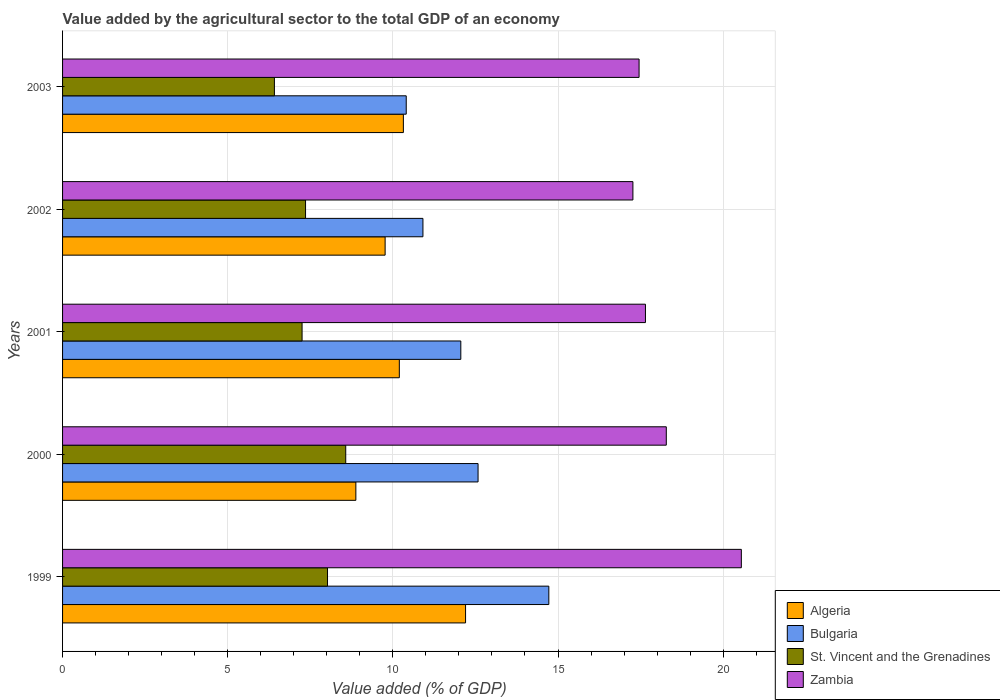How many bars are there on the 1st tick from the bottom?
Ensure brevity in your answer.  4. What is the value added by the agricultural sector to the total GDP in St. Vincent and the Grenadines in 2000?
Give a very brief answer. 8.57. Across all years, what is the maximum value added by the agricultural sector to the total GDP in St. Vincent and the Grenadines?
Your answer should be very brief. 8.57. Across all years, what is the minimum value added by the agricultural sector to the total GDP in Algeria?
Provide a succinct answer. 8.88. In which year was the value added by the agricultural sector to the total GDP in Algeria maximum?
Give a very brief answer. 1999. In which year was the value added by the agricultural sector to the total GDP in Algeria minimum?
Keep it short and to the point. 2000. What is the total value added by the agricultural sector to the total GDP in St. Vincent and the Grenadines in the graph?
Ensure brevity in your answer.  37.62. What is the difference between the value added by the agricultural sector to the total GDP in Zambia in 1999 and that in 2001?
Give a very brief answer. 2.9. What is the difference between the value added by the agricultural sector to the total GDP in Zambia in 1999 and the value added by the agricultural sector to the total GDP in St. Vincent and the Grenadines in 2003?
Your answer should be very brief. 14.14. What is the average value added by the agricultural sector to the total GDP in Bulgaria per year?
Provide a succinct answer. 12.13. In the year 2002, what is the difference between the value added by the agricultural sector to the total GDP in St. Vincent and the Grenadines and value added by the agricultural sector to the total GDP in Zambia?
Your response must be concise. -9.91. What is the ratio of the value added by the agricultural sector to the total GDP in St. Vincent and the Grenadines in 1999 to that in 2000?
Give a very brief answer. 0.94. What is the difference between the highest and the second highest value added by the agricultural sector to the total GDP in Bulgaria?
Offer a very short reply. 2.14. What is the difference between the highest and the lowest value added by the agricultural sector to the total GDP in Bulgaria?
Your response must be concise. 4.32. In how many years, is the value added by the agricultural sector to the total GDP in Bulgaria greater than the average value added by the agricultural sector to the total GDP in Bulgaria taken over all years?
Offer a very short reply. 2. What does the 4th bar from the bottom in 2001 represents?
Keep it short and to the point. Zambia. Is it the case that in every year, the sum of the value added by the agricultural sector to the total GDP in Zambia and value added by the agricultural sector to the total GDP in St. Vincent and the Grenadines is greater than the value added by the agricultural sector to the total GDP in Algeria?
Your answer should be very brief. Yes. How many years are there in the graph?
Your answer should be very brief. 5. What is the difference between two consecutive major ticks on the X-axis?
Your response must be concise. 5. Does the graph contain grids?
Provide a short and direct response. Yes. How many legend labels are there?
Ensure brevity in your answer.  4. How are the legend labels stacked?
Offer a terse response. Vertical. What is the title of the graph?
Provide a short and direct response. Value added by the agricultural sector to the total GDP of an economy. What is the label or title of the X-axis?
Keep it short and to the point. Value added (% of GDP). What is the Value added (% of GDP) of Algeria in 1999?
Give a very brief answer. 12.2. What is the Value added (% of GDP) in Bulgaria in 1999?
Offer a terse response. 14.72. What is the Value added (% of GDP) of St. Vincent and the Grenadines in 1999?
Your answer should be compact. 8.02. What is the Value added (% of GDP) of Zambia in 1999?
Offer a very short reply. 20.55. What is the Value added (% of GDP) of Algeria in 2000?
Make the answer very short. 8.88. What is the Value added (% of GDP) of Bulgaria in 2000?
Your answer should be compact. 12.58. What is the Value added (% of GDP) of St. Vincent and the Grenadines in 2000?
Your answer should be compact. 8.57. What is the Value added (% of GDP) of Zambia in 2000?
Provide a short and direct response. 18.28. What is the Value added (% of GDP) in Algeria in 2001?
Make the answer very short. 10.2. What is the Value added (% of GDP) of Bulgaria in 2001?
Give a very brief answer. 12.06. What is the Value added (% of GDP) of St. Vincent and the Grenadines in 2001?
Ensure brevity in your answer.  7.25. What is the Value added (% of GDP) of Zambia in 2001?
Keep it short and to the point. 17.65. What is the Value added (% of GDP) of Algeria in 2002?
Your answer should be very brief. 9.77. What is the Value added (% of GDP) in Bulgaria in 2002?
Your answer should be compact. 10.91. What is the Value added (% of GDP) in St. Vincent and the Grenadines in 2002?
Give a very brief answer. 7.36. What is the Value added (% of GDP) of Zambia in 2002?
Your answer should be compact. 17.27. What is the Value added (% of GDP) in Algeria in 2003?
Keep it short and to the point. 10.32. What is the Value added (% of GDP) in Bulgaria in 2003?
Your response must be concise. 10.4. What is the Value added (% of GDP) of St. Vincent and the Grenadines in 2003?
Ensure brevity in your answer.  6.41. What is the Value added (% of GDP) in Zambia in 2003?
Offer a very short reply. 17.45. Across all years, what is the maximum Value added (% of GDP) in Algeria?
Your answer should be very brief. 12.2. Across all years, what is the maximum Value added (% of GDP) in Bulgaria?
Provide a short and direct response. 14.72. Across all years, what is the maximum Value added (% of GDP) in St. Vincent and the Grenadines?
Give a very brief answer. 8.57. Across all years, what is the maximum Value added (% of GDP) in Zambia?
Keep it short and to the point. 20.55. Across all years, what is the minimum Value added (% of GDP) of Algeria?
Give a very brief answer. 8.88. Across all years, what is the minimum Value added (% of GDP) of Bulgaria?
Make the answer very short. 10.4. Across all years, what is the minimum Value added (% of GDP) in St. Vincent and the Grenadines?
Your response must be concise. 6.41. Across all years, what is the minimum Value added (% of GDP) of Zambia?
Make the answer very short. 17.27. What is the total Value added (% of GDP) in Algeria in the graph?
Give a very brief answer. 51.36. What is the total Value added (% of GDP) in Bulgaria in the graph?
Ensure brevity in your answer.  60.67. What is the total Value added (% of GDP) of St. Vincent and the Grenadines in the graph?
Keep it short and to the point. 37.62. What is the total Value added (% of GDP) in Zambia in the graph?
Ensure brevity in your answer.  91.2. What is the difference between the Value added (% of GDP) of Algeria in 1999 and that in 2000?
Provide a succinct answer. 3.32. What is the difference between the Value added (% of GDP) of Bulgaria in 1999 and that in 2000?
Your answer should be very brief. 2.14. What is the difference between the Value added (% of GDP) in St. Vincent and the Grenadines in 1999 and that in 2000?
Keep it short and to the point. -0.55. What is the difference between the Value added (% of GDP) in Zambia in 1999 and that in 2000?
Provide a short and direct response. 2.27. What is the difference between the Value added (% of GDP) in Algeria in 1999 and that in 2001?
Your answer should be very brief. 2.01. What is the difference between the Value added (% of GDP) of Bulgaria in 1999 and that in 2001?
Provide a succinct answer. 2.66. What is the difference between the Value added (% of GDP) in St. Vincent and the Grenadines in 1999 and that in 2001?
Keep it short and to the point. 0.77. What is the difference between the Value added (% of GDP) of Zambia in 1999 and that in 2001?
Provide a succinct answer. 2.9. What is the difference between the Value added (% of GDP) in Algeria in 1999 and that in 2002?
Your response must be concise. 2.44. What is the difference between the Value added (% of GDP) in Bulgaria in 1999 and that in 2002?
Offer a terse response. 3.81. What is the difference between the Value added (% of GDP) of St. Vincent and the Grenadines in 1999 and that in 2002?
Offer a very short reply. 0.67. What is the difference between the Value added (% of GDP) of Zambia in 1999 and that in 2002?
Offer a terse response. 3.28. What is the difference between the Value added (% of GDP) of Algeria in 1999 and that in 2003?
Make the answer very short. 1.88. What is the difference between the Value added (% of GDP) of Bulgaria in 1999 and that in 2003?
Your answer should be very brief. 4.32. What is the difference between the Value added (% of GDP) of St. Vincent and the Grenadines in 1999 and that in 2003?
Provide a succinct answer. 1.61. What is the difference between the Value added (% of GDP) of Zambia in 1999 and that in 2003?
Keep it short and to the point. 3.1. What is the difference between the Value added (% of GDP) of Algeria in 2000 and that in 2001?
Give a very brief answer. -1.32. What is the difference between the Value added (% of GDP) in Bulgaria in 2000 and that in 2001?
Ensure brevity in your answer.  0.52. What is the difference between the Value added (% of GDP) in St. Vincent and the Grenadines in 2000 and that in 2001?
Give a very brief answer. 1.32. What is the difference between the Value added (% of GDP) in Zambia in 2000 and that in 2001?
Offer a terse response. 0.63. What is the difference between the Value added (% of GDP) of Algeria in 2000 and that in 2002?
Give a very brief answer. -0.89. What is the difference between the Value added (% of GDP) of Bulgaria in 2000 and that in 2002?
Your answer should be compact. 1.67. What is the difference between the Value added (% of GDP) in St. Vincent and the Grenadines in 2000 and that in 2002?
Give a very brief answer. 1.22. What is the difference between the Value added (% of GDP) in Zambia in 2000 and that in 2002?
Your answer should be very brief. 1.01. What is the difference between the Value added (% of GDP) of Algeria in 2000 and that in 2003?
Offer a terse response. -1.44. What is the difference between the Value added (% of GDP) of Bulgaria in 2000 and that in 2003?
Provide a succinct answer. 2.17. What is the difference between the Value added (% of GDP) in St. Vincent and the Grenadines in 2000 and that in 2003?
Offer a very short reply. 2.16. What is the difference between the Value added (% of GDP) in Zambia in 2000 and that in 2003?
Your answer should be compact. 0.82. What is the difference between the Value added (% of GDP) in Algeria in 2001 and that in 2002?
Provide a succinct answer. 0.43. What is the difference between the Value added (% of GDP) of Bulgaria in 2001 and that in 2002?
Your response must be concise. 1.15. What is the difference between the Value added (% of GDP) in St. Vincent and the Grenadines in 2001 and that in 2002?
Provide a short and direct response. -0.1. What is the difference between the Value added (% of GDP) in Zambia in 2001 and that in 2002?
Your answer should be very brief. 0.38. What is the difference between the Value added (% of GDP) in Algeria in 2001 and that in 2003?
Offer a very short reply. -0.12. What is the difference between the Value added (% of GDP) of Bulgaria in 2001 and that in 2003?
Ensure brevity in your answer.  1.65. What is the difference between the Value added (% of GDP) in St. Vincent and the Grenadines in 2001 and that in 2003?
Offer a terse response. 0.84. What is the difference between the Value added (% of GDP) of Zambia in 2001 and that in 2003?
Give a very brief answer. 0.19. What is the difference between the Value added (% of GDP) of Algeria in 2002 and that in 2003?
Give a very brief answer. -0.55. What is the difference between the Value added (% of GDP) of Bulgaria in 2002 and that in 2003?
Offer a very short reply. 0.51. What is the difference between the Value added (% of GDP) in St. Vincent and the Grenadines in 2002 and that in 2003?
Provide a short and direct response. 0.94. What is the difference between the Value added (% of GDP) of Zambia in 2002 and that in 2003?
Your answer should be compact. -0.19. What is the difference between the Value added (% of GDP) of Algeria in 1999 and the Value added (% of GDP) of Bulgaria in 2000?
Offer a terse response. -0.38. What is the difference between the Value added (% of GDP) in Algeria in 1999 and the Value added (% of GDP) in St. Vincent and the Grenadines in 2000?
Your response must be concise. 3.63. What is the difference between the Value added (% of GDP) in Algeria in 1999 and the Value added (% of GDP) in Zambia in 2000?
Make the answer very short. -6.08. What is the difference between the Value added (% of GDP) in Bulgaria in 1999 and the Value added (% of GDP) in St. Vincent and the Grenadines in 2000?
Keep it short and to the point. 6.15. What is the difference between the Value added (% of GDP) of Bulgaria in 1999 and the Value added (% of GDP) of Zambia in 2000?
Your answer should be compact. -3.56. What is the difference between the Value added (% of GDP) in St. Vincent and the Grenadines in 1999 and the Value added (% of GDP) in Zambia in 2000?
Keep it short and to the point. -10.26. What is the difference between the Value added (% of GDP) in Algeria in 1999 and the Value added (% of GDP) in Bulgaria in 2001?
Provide a short and direct response. 0.14. What is the difference between the Value added (% of GDP) in Algeria in 1999 and the Value added (% of GDP) in St. Vincent and the Grenadines in 2001?
Provide a succinct answer. 4.95. What is the difference between the Value added (% of GDP) of Algeria in 1999 and the Value added (% of GDP) of Zambia in 2001?
Offer a very short reply. -5.45. What is the difference between the Value added (% of GDP) of Bulgaria in 1999 and the Value added (% of GDP) of St. Vincent and the Grenadines in 2001?
Your answer should be compact. 7.47. What is the difference between the Value added (% of GDP) in Bulgaria in 1999 and the Value added (% of GDP) in Zambia in 2001?
Ensure brevity in your answer.  -2.93. What is the difference between the Value added (% of GDP) in St. Vincent and the Grenadines in 1999 and the Value added (% of GDP) in Zambia in 2001?
Ensure brevity in your answer.  -9.63. What is the difference between the Value added (% of GDP) in Algeria in 1999 and the Value added (% of GDP) in Bulgaria in 2002?
Make the answer very short. 1.29. What is the difference between the Value added (% of GDP) in Algeria in 1999 and the Value added (% of GDP) in St. Vincent and the Grenadines in 2002?
Provide a succinct answer. 4.84. What is the difference between the Value added (% of GDP) in Algeria in 1999 and the Value added (% of GDP) in Zambia in 2002?
Your answer should be very brief. -5.07. What is the difference between the Value added (% of GDP) of Bulgaria in 1999 and the Value added (% of GDP) of St. Vincent and the Grenadines in 2002?
Make the answer very short. 7.37. What is the difference between the Value added (% of GDP) in Bulgaria in 1999 and the Value added (% of GDP) in Zambia in 2002?
Offer a terse response. -2.55. What is the difference between the Value added (% of GDP) in St. Vincent and the Grenadines in 1999 and the Value added (% of GDP) in Zambia in 2002?
Make the answer very short. -9.25. What is the difference between the Value added (% of GDP) in Algeria in 1999 and the Value added (% of GDP) in Bulgaria in 2003?
Make the answer very short. 1.8. What is the difference between the Value added (% of GDP) in Algeria in 1999 and the Value added (% of GDP) in St. Vincent and the Grenadines in 2003?
Your response must be concise. 5.79. What is the difference between the Value added (% of GDP) of Algeria in 1999 and the Value added (% of GDP) of Zambia in 2003?
Give a very brief answer. -5.25. What is the difference between the Value added (% of GDP) of Bulgaria in 1999 and the Value added (% of GDP) of St. Vincent and the Grenadines in 2003?
Keep it short and to the point. 8.31. What is the difference between the Value added (% of GDP) of Bulgaria in 1999 and the Value added (% of GDP) of Zambia in 2003?
Your answer should be compact. -2.73. What is the difference between the Value added (% of GDP) in St. Vincent and the Grenadines in 1999 and the Value added (% of GDP) in Zambia in 2003?
Keep it short and to the point. -9.43. What is the difference between the Value added (% of GDP) in Algeria in 2000 and the Value added (% of GDP) in Bulgaria in 2001?
Give a very brief answer. -3.18. What is the difference between the Value added (% of GDP) of Algeria in 2000 and the Value added (% of GDP) of St. Vincent and the Grenadines in 2001?
Your answer should be very brief. 1.63. What is the difference between the Value added (% of GDP) of Algeria in 2000 and the Value added (% of GDP) of Zambia in 2001?
Make the answer very short. -8.77. What is the difference between the Value added (% of GDP) of Bulgaria in 2000 and the Value added (% of GDP) of St. Vincent and the Grenadines in 2001?
Offer a terse response. 5.33. What is the difference between the Value added (% of GDP) of Bulgaria in 2000 and the Value added (% of GDP) of Zambia in 2001?
Offer a very short reply. -5.07. What is the difference between the Value added (% of GDP) of St. Vincent and the Grenadines in 2000 and the Value added (% of GDP) of Zambia in 2001?
Offer a very short reply. -9.07. What is the difference between the Value added (% of GDP) of Algeria in 2000 and the Value added (% of GDP) of Bulgaria in 2002?
Provide a succinct answer. -2.03. What is the difference between the Value added (% of GDP) in Algeria in 2000 and the Value added (% of GDP) in St. Vincent and the Grenadines in 2002?
Your answer should be compact. 1.52. What is the difference between the Value added (% of GDP) in Algeria in 2000 and the Value added (% of GDP) in Zambia in 2002?
Your answer should be compact. -8.39. What is the difference between the Value added (% of GDP) in Bulgaria in 2000 and the Value added (% of GDP) in St. Vincent and the Grenadines in 2002?
Your response must be concise. 5.22. What is the difference between the Value added (% of GDP) in Bulgaria in 2000 and the Value added (% of GDP) in Zambia in 2002?
Offer a very short reply. -4.69. What is the difference between the Value added (% of GDP) of St. Vincent and the Grenadines in 2000 and the Value added (% of GDP) of Zambia in 2002?
Keep it short and to the point. -8.69. What is the difference between the Value added (% of GDP) of Algeria in 2000 and the Value added (% of GDP) of Bulgaria in 2003?
Offer a very short reply. -1.52. What is the difference between the Value added (% of GDP) of Algeria in 2000 and the Value added (% of GDP) of St. Vincent and the Grenadines in 2003?
Your answer should be compact. 2.47. What is the difference between the Value added (% of GDP) of Algeria in 2000 and the Value added (% of GDP) of Zambia in 2003?
Give a very brief answer. -8.57. What is the difference between the Value added (% of GDP) in Bulgaria in 2000 and the Value added (% of GDP) in St. Vincent and the Grenadines in 2003?
Provide a short and direct response. 6.17. What is the difference between the Value added (% of GDP) in Bulgaria in 2000 and the Value added (% of GDP) in Zambia in 2003?
Provide a succinct answer. -4.88. What is the difference between the Value added (% of GDP) in St. Vincent and the Grenadines in 2000 and the Value added (% of GDP) in Zambia in 2003?
Ensure brevity in your answer.  -8.88. What is the difference between the Value added (% of GDP) of Algeria in 2001 and the Value added (% of GDP) of Bulgaria in 2002?
Offer a terse response. -0.71. What is the difference between the Value added (% of GDP) of Algeria in 2001 and the Value added (% of GDP) of St. Vincent and the Grenadines in 2002?
Your answer should be compact. 2.84. What is the difference between the Value added (% of GDP) of Algeria in 2001 and the Value added (% of GDP) of Zambia in 2002?
Your answer should be compact. -7.07. What is the difference between the Value added (% of GDP) of Bulgaria in 2001 and the Value added (% of GDP) of St. Vincent and the Grenadines in 2002?
Provide a succinct answer. 4.7. What is the difference between the Value added (% of GDP) in Bulgaria in 2001 and the Value added (% of GDP) in Zambia in 2002?
Keep it short and to the point. -5.21. What is the difference between the Value added (% of GDP) of St. Vincent and the Grenadines in 2001 and the Value added (% of GDP) of Zambia in 2002?
Give a very brief answer. -10.02. What is the difference between the Value added (% of GDP) of Algeria in 2001 and the Value added (% of GDP) of Bulgaria in 2003?
Provide a short and direct response. -0.21. What is the difference between the Value added (% of GDP) of Algeria in 2001 and the Value added (% of GDP) of St. Vincent and the Grenadines in 2003?
Offer a very short reply. 3.78. What is the difference between the Value added (% of GDP) of Algeria in 2001 and the Value added (% of GDP) of Zambia in 2003?
Provide a short and direct response. -7.26. What is the difference between the Value added (% of GDP) of Bulgaria in 2001 and the Value added (% of GDP) of St. Vincent and the Grenadines in 2003?
Your response must be concise. 5.64. What is the difference between the Value added (% of GDP) in Bulgaria in 2001 and the Value added (% of GDP) in Zambia in 2003?
Provide a succinct answer. -5.4. What is the difference between the Value added (% of GDP) in St. Vincent and the Grenadines in 2001 and the Value added (% of GDP) in Zambia in 2003?
Provide a short and direct response. -10.2. What is the difference between the Value added (% of GDP) in Algeria in 2002 and the Value added (% of GDP) in Bulgaria in 2003?
Your response must be concise. -0.64. What is the difference between the Value added (% of GDP) in Algeria in 2002 and the Value added (% of GDP) in St. Vincent and the Grenadines in 2003?
Ensure brevity in your answer.  3.35. What is the difference between the Value added (% of GDP) of Algeria in 2002 and the Value added (% of GDP) of Zambia in 2003?
Offer a very short reply. -7.69. What is the difference between the Value added (% of GDP) in Bulgaria in 2002 and the Value added (% of GDP) in St. Vincent and the Grenadines in 2003?
Offer a very short reply. 4.5. What is the difference between the Value added (% of GDP) of Bulgaria in 2002 and the Value added (% of GDP) of Zambia in 2003?
Provide a succinct answer. -6.54. What is the difference between the Value added (% of GDP) of St. Vincent and the Grenadines in 2002 and the Value added (% of GDP) of Zambia in 2003?
Keep it short and to the point. -10.1. What is the average Value added (% of GDP) of Algeria per year?
Make the answer very short. 10.27. What is the average Value added (% of GDP) of Bulgaria per year?
Ensure brevity in your answer.  12.13. What is the average Value added (% of GDP) of St. Vincent and the Grenadines per year?
Provide a succinct answer. 7.52. What is the average Value added (% of GDP) of Zambia per year?
Your answer should be very brief. 18.24. In the year 1999, what is the difference between the Value added (% of GDP) of Algeria and Value added (% of GDP) of Bulgaria?
Your response must be concise. -2.52. In the year 1999, what is the difference between the Value added (% of GDP) in Algeria and Value added (% of GDP) in St. Vincent and the Grenadines?
Keep it short and to the point. 4.18. In the year 1999, what is the difference between the Value added (% of GDP) in Algeria and Value added (% of GDP) in Zambia?
Your response must be concise. -8.35. In the year 1999, what is the difference between the Value added (% of GDP) in Bulgaria and Value added (% of GDP) in St. Vincent and the Grenadines?
Provide a succinct answer. 6.7. In the year 1999, what is the difference between the Value added (% of GDP) of Bulgaria and Value added (% of GDP) of Zambia?
Keep it short and to the point. -5.83. In the year 1999, what is the difference between the Value added (% of GDP) of St. Vincent and the Grenadines and Value added (% of GDP) of Zambia?
Your answer should be compact. -12.53. In the year 2000, what is the difference between the Value added (% of GDP) of Algeria and Value added (% of GDP) of Bulgaria?
Your answer should be very brief. -3.7. In the year 2000, what is the difference between the Value added (% of GDP) of Algeria and Value added (% of GDP) of St. Vincent and the Grenadines?
Make the answer very short. 0.31. In the year 2000, what is the difference between the Value added (% of GDP) in Algeria and Value added (% of GDP) in Zambia?
Offer a very short reply. -9.4. In the year 2000, what is the difference between the Value added (% of GDP) in Bulgaria and Value added (% of GDP) in St. Vincent and the Grenadines?
Give a very brief answer. 4.01. In the year 2000, what is the difference between the Value added (% of GDP) in Bulgaria and Value added (% of GDP) in Zambia?
Your response must be concise. -5.7. In the year 2000, what is the difference between the Value added (% of GDP) of St. Vincent and the Grenadines and Value added (% of GDP) of Zambia?
Give a very brief answer. -9.71. In the year 2001, what is the difference between the Value added (% of GDP) in Algeria and Value added (% of GDP) in Bulgaria?
Offer a terse response. -1.86. In the year 2001, what is the difference between the Value added (% of GDP) of Algeria and Value added (% of GDP) of St. Vincent and the Grenadines?
Offer a terse response. 2.94. In the year 2001, what is the difference between the Value added (% of GDP) in Algeria and Value added (% of GDP) in Zambia?
Make the answer very short. -7.45. In the year 2001, what is the difference between the Value added (% of GDP) in Bulgaria and Value added (% of GDP) in St. Vincent and the Grenadines?
Offer a very short reply. 4.81. In the year 2001, what is the difference between the Value added (% of GDP) of Bulgaria and Value added (% of GDP) of Zambia?
Your response must be concise. -5.59. In the year 2001, what is the difference between the Value added (% of GDP) of St. Vincent and the Grenadines and Value added (% of GDP) of Zambia?
Your answer should be compact. -10.4. In the year 2002, what is the difference between the Value added (% of GDP) in Algeria and Value added (% of GDP) in Bulgaria?
Offer a terse response. -1.14. In the year 2002, what is the difference between the Value added (% of GDP) in Algeria and Value added (% of GDP) in St. Vincent and the Grenadines?
Offer a very short reply. 2.41. In the year 2002, what is the difference between the Value added (% of GDP) in Algeria and Value added (% of GDP) in Zambia?
Your answer should be compact. -7.5. In the year 2002, what is the difference between the Value added (% of GDP) of Bulgaria and Value added (% of GDP) of St. Vincent and the Grenadines?
Provide a short and direct response. 3.55. In the year 2002, what is the difference between the Value added (% of GDP) of Bulgaria and Value added (% of GDP) of Zambia?
Provide a succinct answer. -6.36. In the year 2002, what is the difference between the Value added (% of GDP) in St. Vincent and the Grenadines and Value added (% of GDP) in Zambia?
Your response must be concise. -9.91. In the year 2003, what is the difference between the Value added (% of GDP) of Algeria and Value added (% of GDP) of Bulgaria?
Ensure brevity in your answer.  -0.09. In the year 2003, what is the difference between the Value added (% of GDP) of Algeria and Value added (% of GDP) of St. Vincent and the Grenadines?
Offer a very short reply. 3.9. In the year 2003, what is the difference between the Value added (% of GDP) in Algeria and Value added (% of GDP) in Zambia?
Your answer should be compact. -7.14. In the year 2003, what is the difference between the Value added (% of GDP) of Bulgaria and Value added (% of GDP) of St. Vincent and the Grenadines?
Provide a short and direct response. 3.99. In the year 2003, what is the difference between the Value added (% of GDP) in Bulgaria and Value added (% of GDP) in Zambia?
Provide a short and direct response. -7.05. In the year 2003, what is the difference between the Value added (% of GDP) of St. Vincent and the Grenadines and Value added (% of GDP) of Zambia?
Your answer should be compact. -11.04. What is the ratio of the Value added (% of GDP) of Algeria in 1999 to that in 2000?
Keep it short and to the point. 1.37. What is the ratio of the Value added (% of GDP) of Bulgaria in 1999 to that in 2000?
Provide a succinct answer. 1.17. What is the ratio of the Value added (% of GDP) in St. Vincent and the Grenadines in 1999 to that in 2000?
Give a very brief answer. 0.94. What is the ratio of the Value added (% of GDP) of Zambia in 1999 to that in 2000?
Make the answer very short. 1.12. What is the ratio of the Value added (% of GDP) in Algeria in 1999 to that in 2001?
Offer a very short reply. 1.2. What is the ratio of the Value added (% of GDP) of Bulgaria in 1999 to that in 2001?
Offer a very short reply. 1.22. What is the ratio of the Value added (% of GDP) of St. Vincent and the Grenadines in 1999 to that in 2001?
Make the answer very short. 1.11. What is the ratio of the Value added (% of GDP) of Zambia in 1999 to that in 2001?
Keep it short and to the point. 1.16. What is the ratio of the Value added (% of GDP) of Algeria in 1999 to that in 2002?
Give a very brief answer. 1.25. What is the ratio of the Value added (% of GDP) of Bulgaria in 1999 to that in 2002?
Make the answer very short. 1.35. What is the ratio of the Value added (% of GDP) in St. Vincent and the Grenadines in 1999 to that in 2002?
Provide a succinct answer. 1.09. What is the ratio of the Value added (% of GDP) of Zambia in 1999 to that in 2002?
Offer a very short reply. 1.19. What is the ratio of the Value added (% of GDP) in Algeria in 1999 to that in 2003?
Give a very brief answer. 1.18. What is the ratio of the Value added (% of GDP) in Bulgaria in 1999 to that in 2003?
Provide a succinct answer. 1.41. What is the ratio of the Value added (% of GDP) of St. Vincent and the Grenadines in 1999 to that in 2003?
Make the answer very short. 1.25. What is the ratio of the Value added (% of GDP) in Zambia in 1999 to that in 2003?
Provide a succinct answer. 1.18. What is the ratio of the Value added (% of GDP) in Algeria in 2000 to that in 2001?
Give a very brief answer. 0.87. What is the ratio of the Value added (% of GDP) in Bulgaria in 2000 to that in 2001?
Your response must be concise. 1.04. What is the ratio of the Value added (% of GDP) in St. Vincent and the Grenadines in 2000 to that in 2001?
Offer a very short reply. 1.18. What is the ratio of the Value added (% of GDP) of Zambia in 2000 to that in 2001?
Give a very brief answer. 1.04. What is the ratio of the Value added (% of GDP) of Algeria in 2000 to that in 2002?
Keep it short and to the point. 0.91. What is the ratio of the Value added (% of GDP) of Bulgaria in 2000 to that in 2002?
Keep it short and to the point. 1.15. What is the ratio of the Value added (% of GDP) in St. Vincent and the Grenadines in 2000 to that in 2002?
Offer a terse response. 1.17. What is the ratio of the Value added (% of GDP) of Zambia in 2000 to that in 2002?
Keep it short and to the point. 1.06. What is the ratio of the Value added (% of GDP) in Algeria in 2000 to that in 2003?
Provide a short and direct response. 0.86. What is the ratio of the Value added (% of GDP) of Bulgaria in 2000 to that in 2003?
Your response must be concise. 1.21. What is the ratio of the Value added (% of GDP) of St. Vincent and the Grenadines in 2000 to that in 2003?
Ensure brevity in your answer.  1.34. What is the ratio of the Value added (% of GDP) of Zambia in 2000 to that in 2003?
Provide a short and direct response. 1.05. What is the ratio of the Value added (% of GDP) in Algeria in 2001 to that in 2002?
Your answer should be compact. 1.04. What is the ratio of the Value added (% of GDP) in Bulgaria in 2001 to that in 2002?
Keep it short and to the point. 1.11. What is the ratio of the Value added (% of GDP) in St. Vincent and the Grenadines in 2001 to that in 2002?
Ensure brevity in your answer.  0.99. What is the ratio of the Value added (% of GDP) in Algeria in 2001 to that in 2003?
Your answer should be compact. 0.99. What is the ratio of the Value added (% of GDP) of Bulgaria in 2001 to that in 2003?
Keep it short and to the point. 1.16. What is the ratio of the Value added (% of GDP) in St. Vincent and the Grenadines in 2001 to that in 2003?
Your answer should be very brief. 1.13. What is the ratio of the Value added (% of GDP) of Algeria in 2002 to that in 2003?
Provide a short and direct response. 0.95. What is the ratio of the Value added (% of GDP) in Bulgaria in 2002 to that in 2003?
Give a very brief answer. 1.05. What is the ratio of the Value added (% of GDP) in St. Vincent and the Grenadines in 2002 to that in 2003?
Give a very brief answer. 1.15. What is the ratio of the Value added (% of GDP) of Zambia in 2002 to that in 2003?
Keep it short and to the point. 0.99. What is the difference between the highest and the second highest Value added (% of GDP) of Algeria?
Provide a short and direct response. 1.88. What is the difference between the highest and the second highest Value added (% of GDP) in Bulgaria?
Offer a terse response. 2.14. What is the difference between the highest and the second highest Value added (% of GDP) in St. Vincent and the Grenadines?
Make the answer very short. 0.55. What is the difference between the highest and the second highest Value added (% of GDP) in Zambia?
Your answer should be compact. 2.27. What is the difference between the highest and the lowest Value added (% of GDP) in Algeria?
Keep it short and to the point. 3.32. What is the difference between the highest and the lowest Value added (% of GDP) of Bulgaria?
Make the answer very short. 4.32. What is the difference between the highest and the lowest Value added (% of GDP) in St. Vincent and the Grenadines?
Offer a very short reply. 2.16. What is the difference between the highest and the lowest Value added (% of GDP) in Zambia?
Keep it short and to the point. 3.28. 